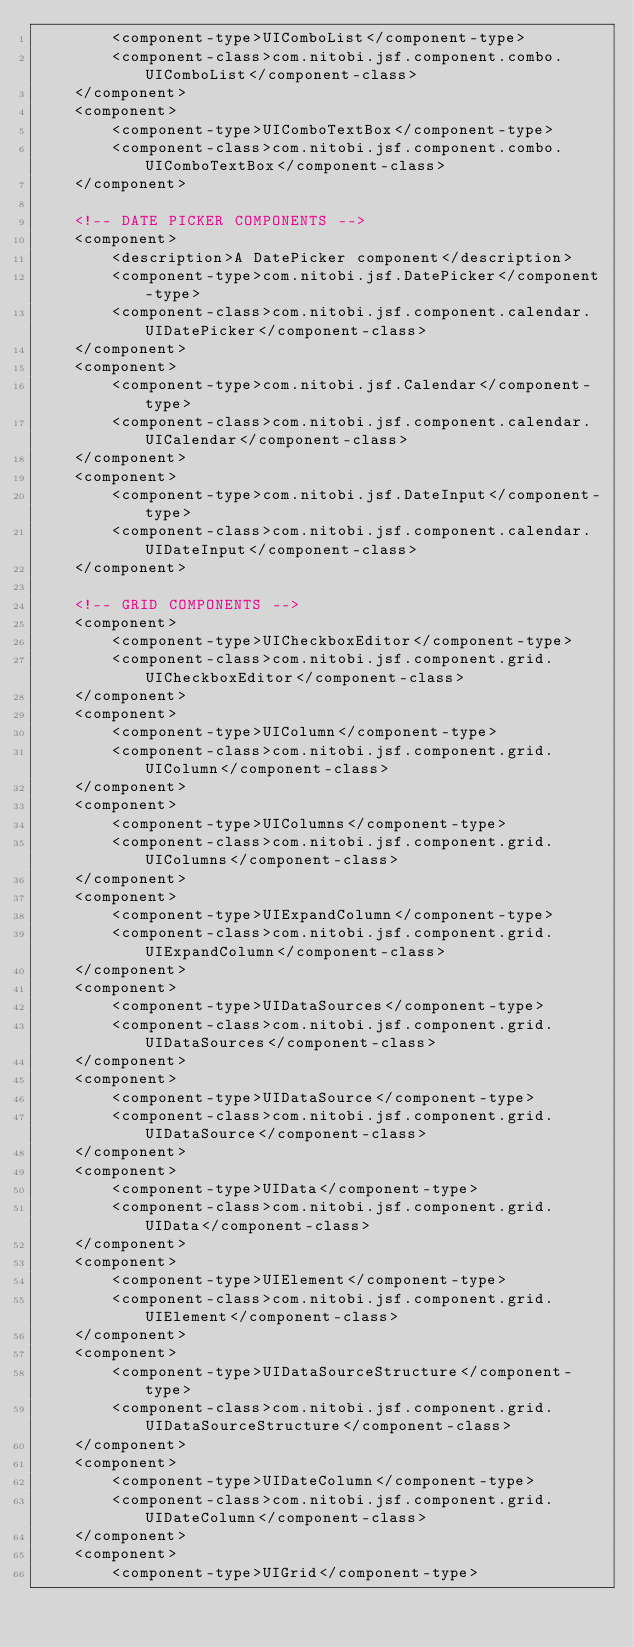Convert code to text. <code><loc_0><loc_0><loc_500><loc_500><_XML_>        <component-type>UIComboList</component-type>
        <component-class>com.nitobi.jsf.component.combo.UIComboList</component-class>
    </component>
    <component>
        <component-type>UIComboTextBox</component-type>
        <component-class>com.nitobi.jsf.component.combo.UIComboTextBox</component-class>
    </component>

    <!-- DATE PICKER COMPONENTS -->
    <component>
        <description>A DatePicker component</description>
        <component-type>com.nitobi.jsf.DatePicker</component-type>
        <component-class>com.nitobi.jsf.component.calendar.UIDatePicker</component-class>
    </component>
    <component>
        <component-type>com.nitobi.jsf.Calendar</component-type>
        <component-class>com.nitobi.jsf.component.calendar.UICalendar</component-class>
    </component>
    <component>
        <component-type>com.nitobi.jsf.DateInput</component-type>
        <component-class>com.nitobi.jsf.component.calendar.UIDateInput</component-class>
    </component>

    <!-- GRID COMPONENTS -->
    <component>
        <component-type>UICheckboxEditor</component-type>
        <component-class>com.nitobi.jsf.component.grid.UICheckboxEditor</component-class>
    </component>
    <component>
        <component-type>UIColumn</component-type>
        <component-class>com.nitobi.jsf.component.grid.UIColumn</component-class>
    </component>
    <component>
        <component-type>UIColumns</component-type>
        <component-class>com.nitobi.jsf.component.grid.UIColumns</component-class>
    </component>
    <component>
        <component-type>UIExpandColumn</component-type>
        <component-class>com.nitobi.jsf.component.grid.UIExpandColumn</component-class>
    </component>
    <component>
        <component-type>UIDataSources</component-type>
        <component-class>com.nitobi.jsf.component.grid.UIDataSources</component-class>
    </component>
    <component>
        <component-type>UIDataSource</component-type>
        <component-class>com.nitobi.jsf.component.grid.UIDataSource</component-class>
    </component>
    <component>
        <component-type>UIData</component-type>
        <component-class>com.nitobi.jsf.component.grid.UIData</component-class>
    </component>
    <component>
        <component-type>UIElement</component-type>
        <component-class>com.nitobi.jsf.component.grid.UIElement</component-class>
    </component>
    <component>
        <component-type>UIDataSourceStructure</component-type>
        <component-class>com.nitobi.jsf.component.grid.UIDataSourceStructure</component-class>
    </component>
    <component>
        <component-type>UIDateColumn</component-type>
        <component-class>com.nitobi.jsf.component.grid.UIDateColumn</component-class>
    </component>
    <component>
        <component-type>UIGrid</component-type></code> 